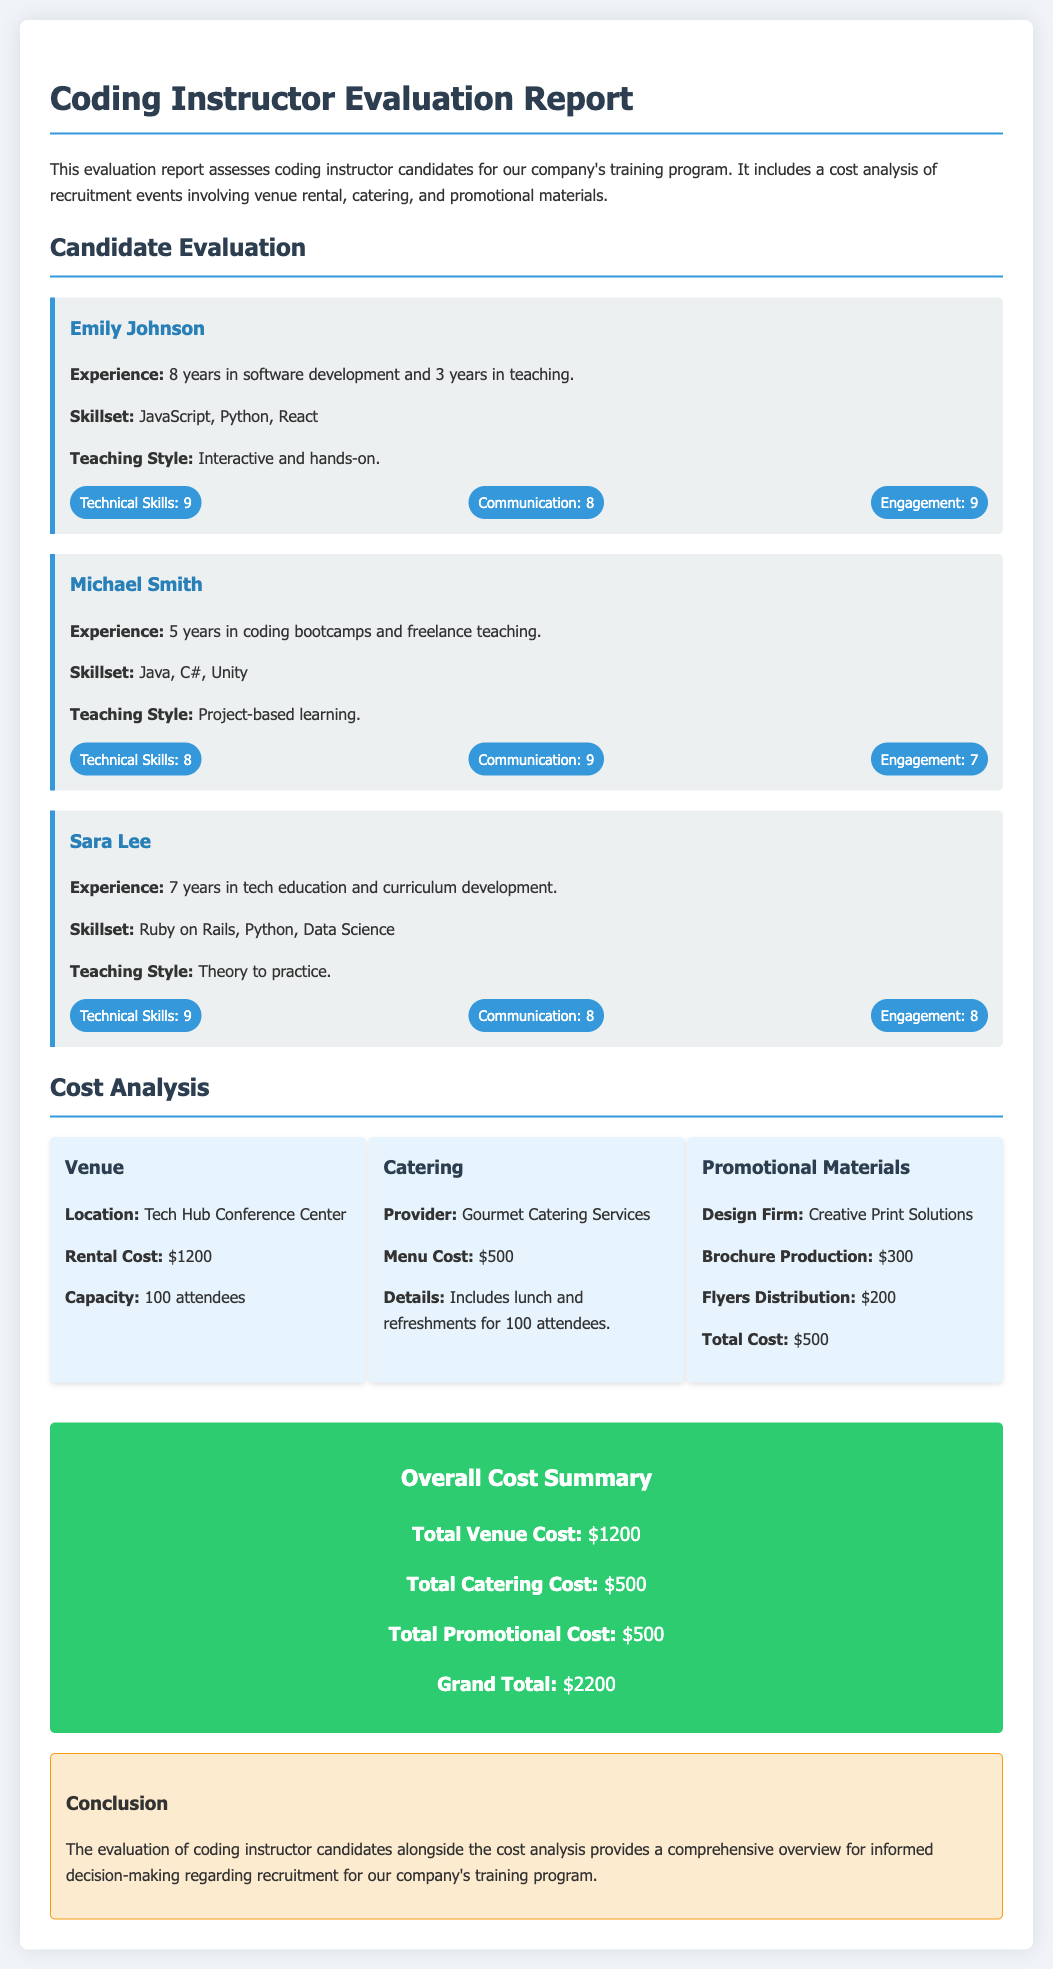What is the name of the first candidate? The first candidate mentioned in the document is Emily Johnson.
Answer: Emily Johnson What is Sara Lee's teaching style? The document states that Sara Lee's teaching style is "Theory to practice."
Answer: Theory to practice What is the total cost for catering? The catering cost detailed in the document is $500.
Answer: $500 How many years of experience does Michael Smith have? Michael Smith has 5 years of experience according to the evaluation.
Answer: 5 years What is the grand total of the overall costs? The document lists the grand total as $2200.
Answer: $2200 Which catering provider is mentioned in the report? The document specifies the catering provider as Gourmet Catering Services.
Answer: Gourmet Catering Services What is the total cost for promotional materials? The document states that the total cost for promotional materials is $500.
Answer: $500 What is the rental cost for the venue? The rental cost for the venue is provided as $1200.
Answer: $1200 How many attendees can the venue accommodate? The capacity of the venue is noted to be 100 attendees.
Answer: 100 attendees 